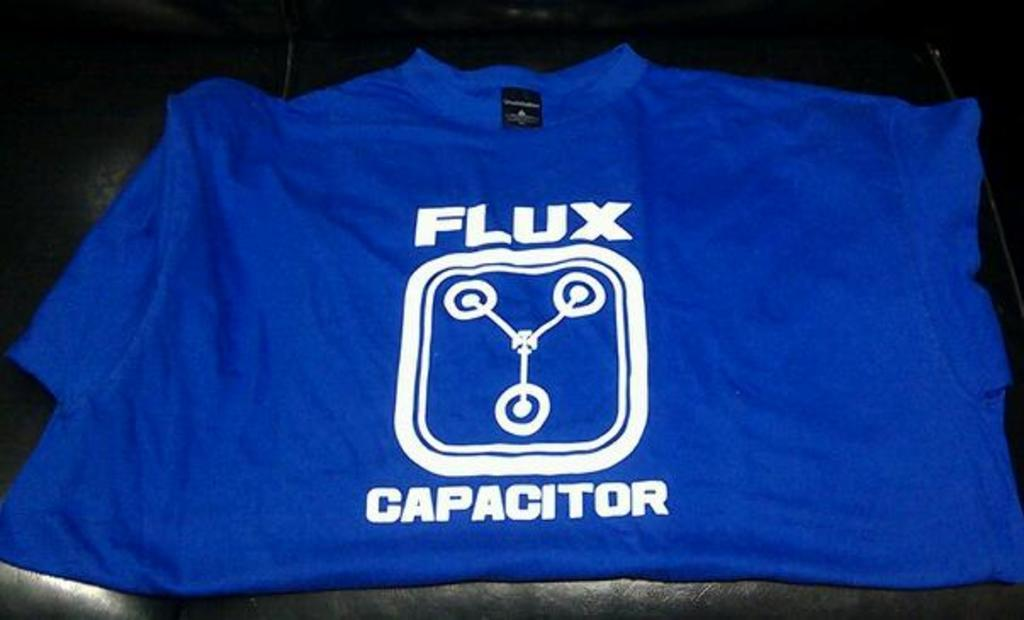<image>
Summarize the visual content of the image. A shirt that says flux capacitor sits on a table. 